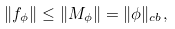<formula> <loc_0><loc_0><loc_500><loc_500>\| f _ { \phi } \| \leq \| M _ { \phi } \| = \| \phi \| _ { c b } ,</formula> 